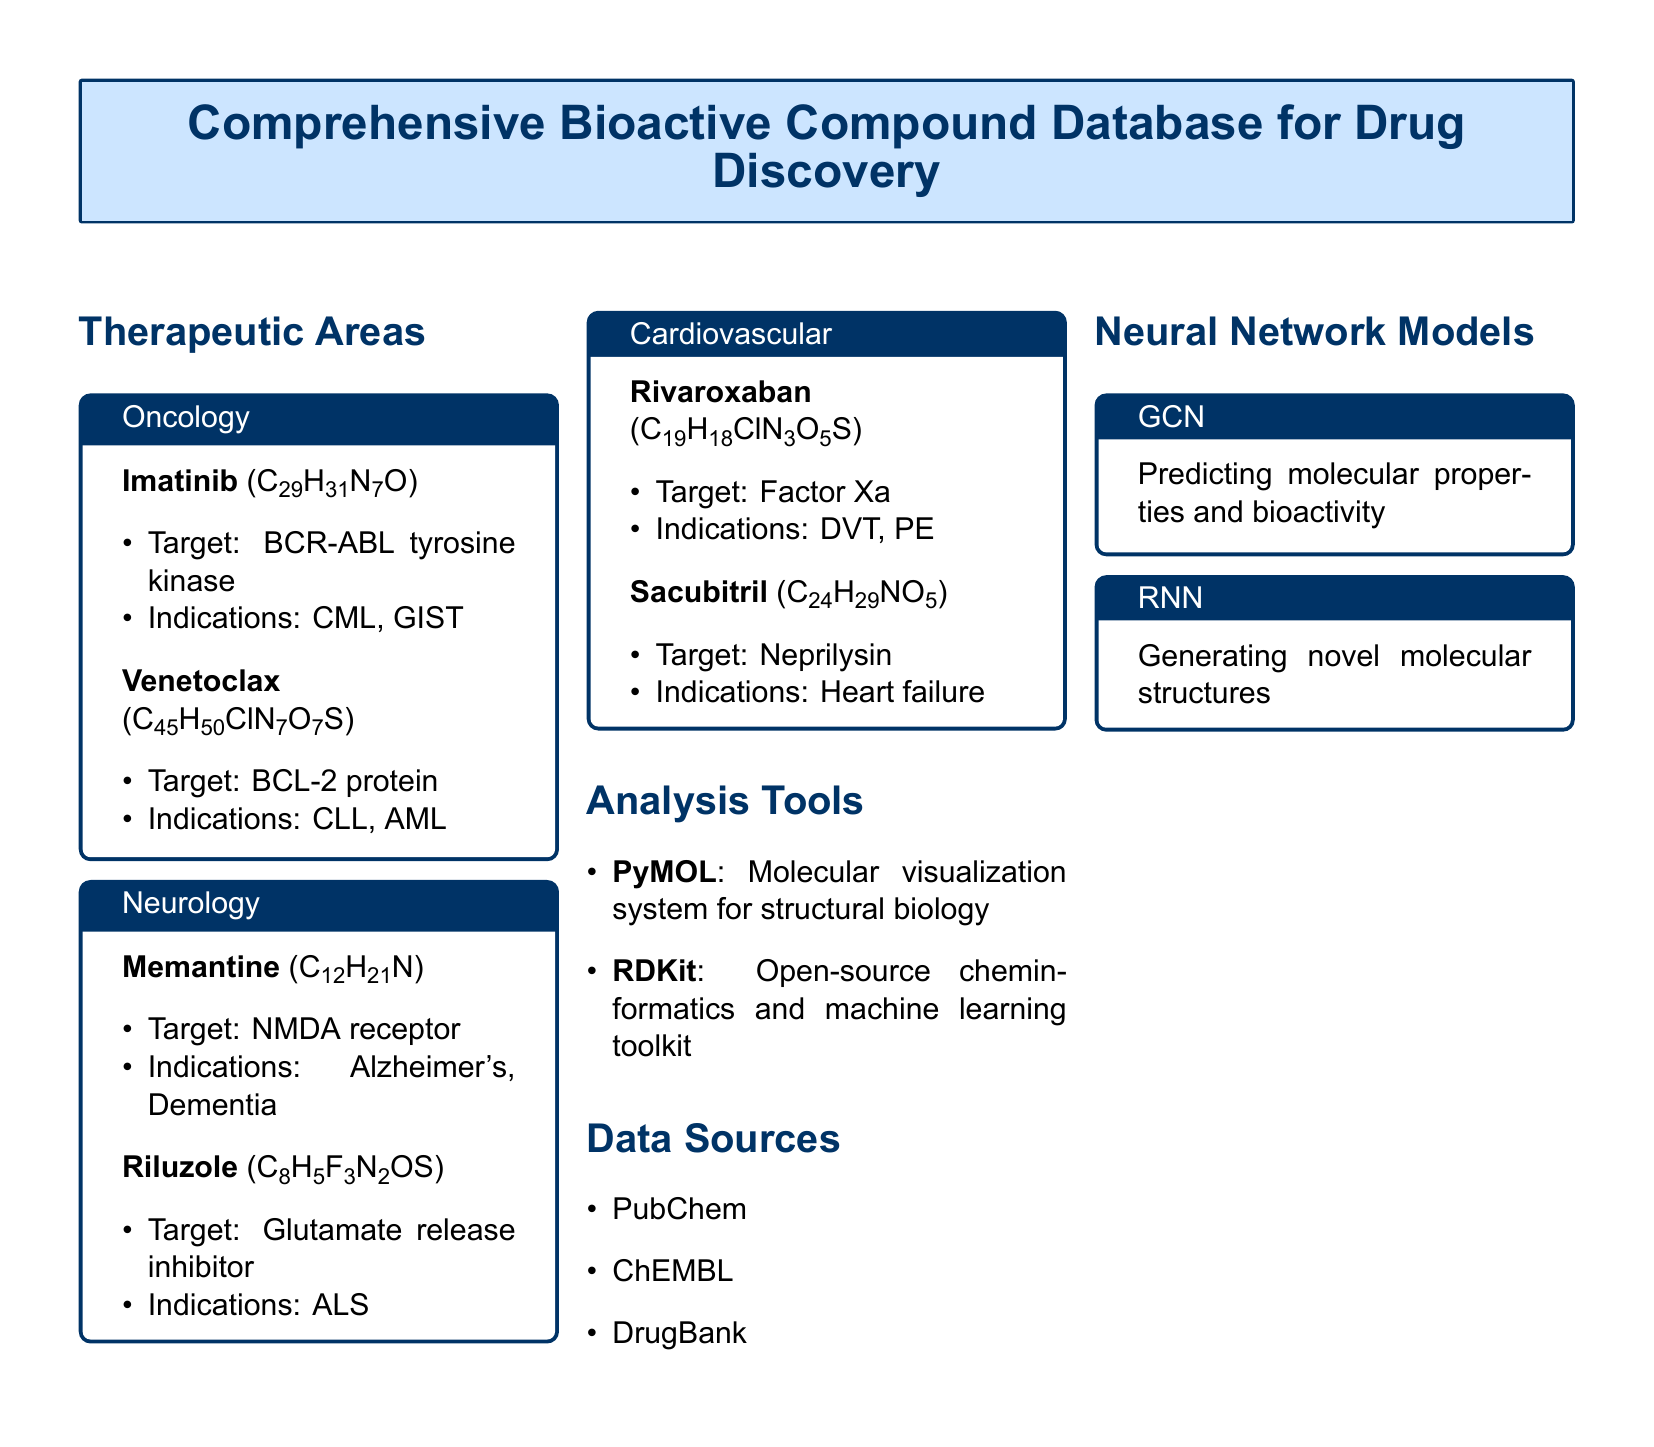What are the indications for Imatinib? The indications for Imatinib, as listed in the document, are chronic myeloid leukemia and gastrointestinal stromal tumors.
Answer: CML, GIST What is the molecular formula for Riluzole? The molecular formula for Riluzole is provided in the document as a chemical structure representation.
Answer: C8H5F3N2OS Who developed the GCN neural network model? The document does not specify an individual or team, rather it identifies the GCN model as a tool for a specific purpose without attribution.
Answer: Not specified What is the target for Rivaroxaban? The target for Rivaroxaban is clearly indicated in the document, which is essential for understanding its mechanism.
Answer: Factor Xa Which therapeutic area includes Memantine? The document lists therapeutic areas in organized sections, specifically attributing Memantine to its correct category.
Answer: Neurology What sources are cited for data in this catalog? The document provides a succinct list of data sources at the end, summarizing where the information was obtained.
Answer: PubChem, ChEMBL, DrugBank How many bioactive compounds are listed under Oncology? By reviewing the Oncology section, one can count the compounds mentioned directly in the document.
Answer: 2 Which analysis tool is used for molecular visualization? This information is available in the analysis tools section, identifying specific software used for related tasks in the document.
Answer: PyMOL What is the purpose of the RNN model mentioned? The document provides a brief description of the RNN model's function, which is indicative of its application in drug discovery.
Answer: Generating novel molecular structures 